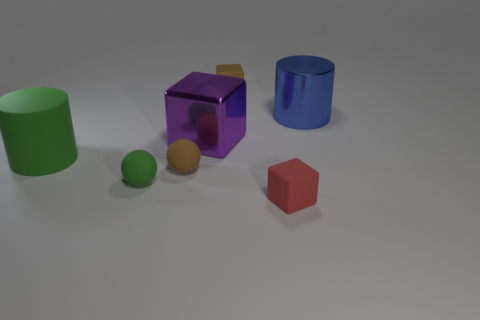How many small things are green rubber cylinders or blue metal cylinders?
Your answer should be compact. 0. What material is the tiny red cube?
Keep it short and to the point. Rubber. What number of other things are there of the same shape as the small green thing?
Your answer should be compact. 1. What size is the purple shiny object?
Make the answer very short. Large. What size is the object that is behind the large matte cylinder and on the left side of the tiny brown rubber block?
Provide a succinct answer. Large. What shape is the tiny object behind the large green rubber object?
Your answer should be very brief. Cube. Is the large blue cylinder made of the same material as the cylinder that is in front of the big blue shiny thing?
Make the answer very short. No. Is the shape of the big green object the same as the big blue shiny object?
Ensure brevity in your answer.  Yes. There is a small brown object that is the same shape as the big purple thing; what is its material?
Your answer should be very brief. Rubber. There is a big thing that is on the left side of the small red cube and on the right side of the green cylinder; what color is it?
Provide a succinct answer. Purple. 